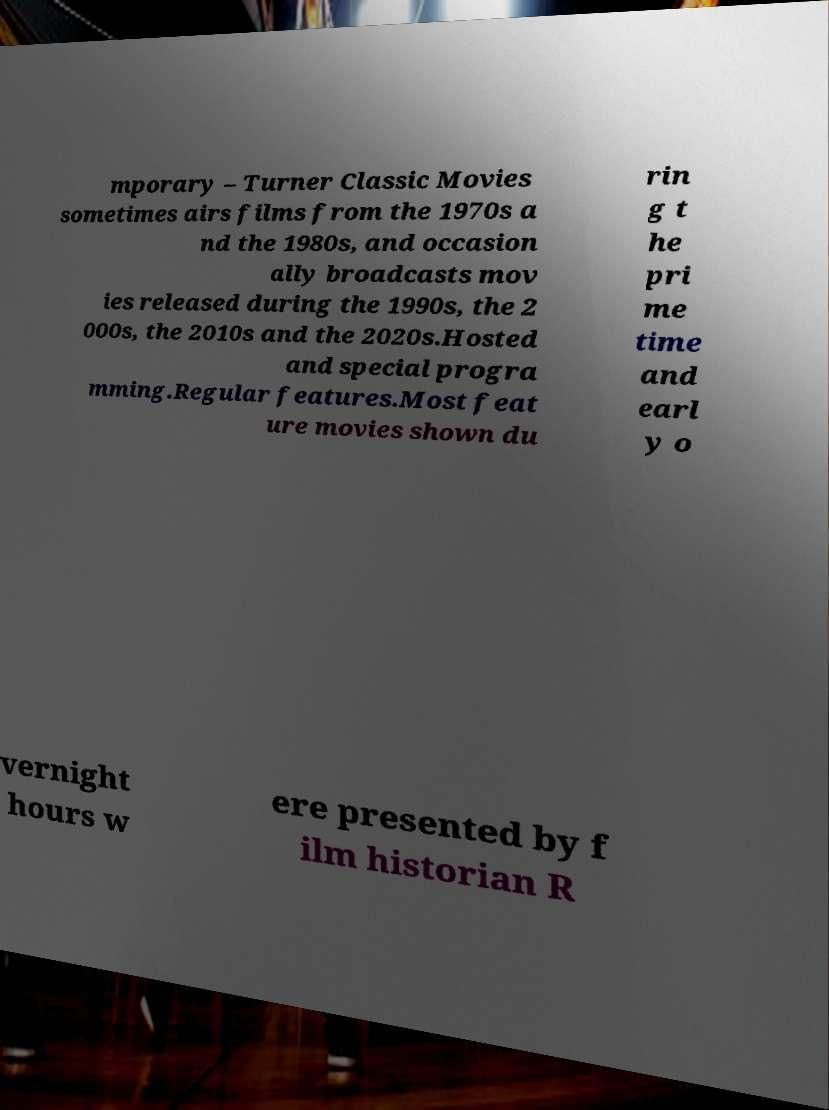Please read and relay the text visible in this image. What does it say? mporary – Turner Classic Movies sometimes airs films from the 1970s a nd the 1980s, and occasion ally broadcasts mov ies released during the 1990s, the 2 000s, the 2010s and the 2020s.Hosted and special progra mming.Regular features.Most feat ure movies shown du rin g t he pri me time and earl y o vernight hours w ere presented by f ilm historian R 